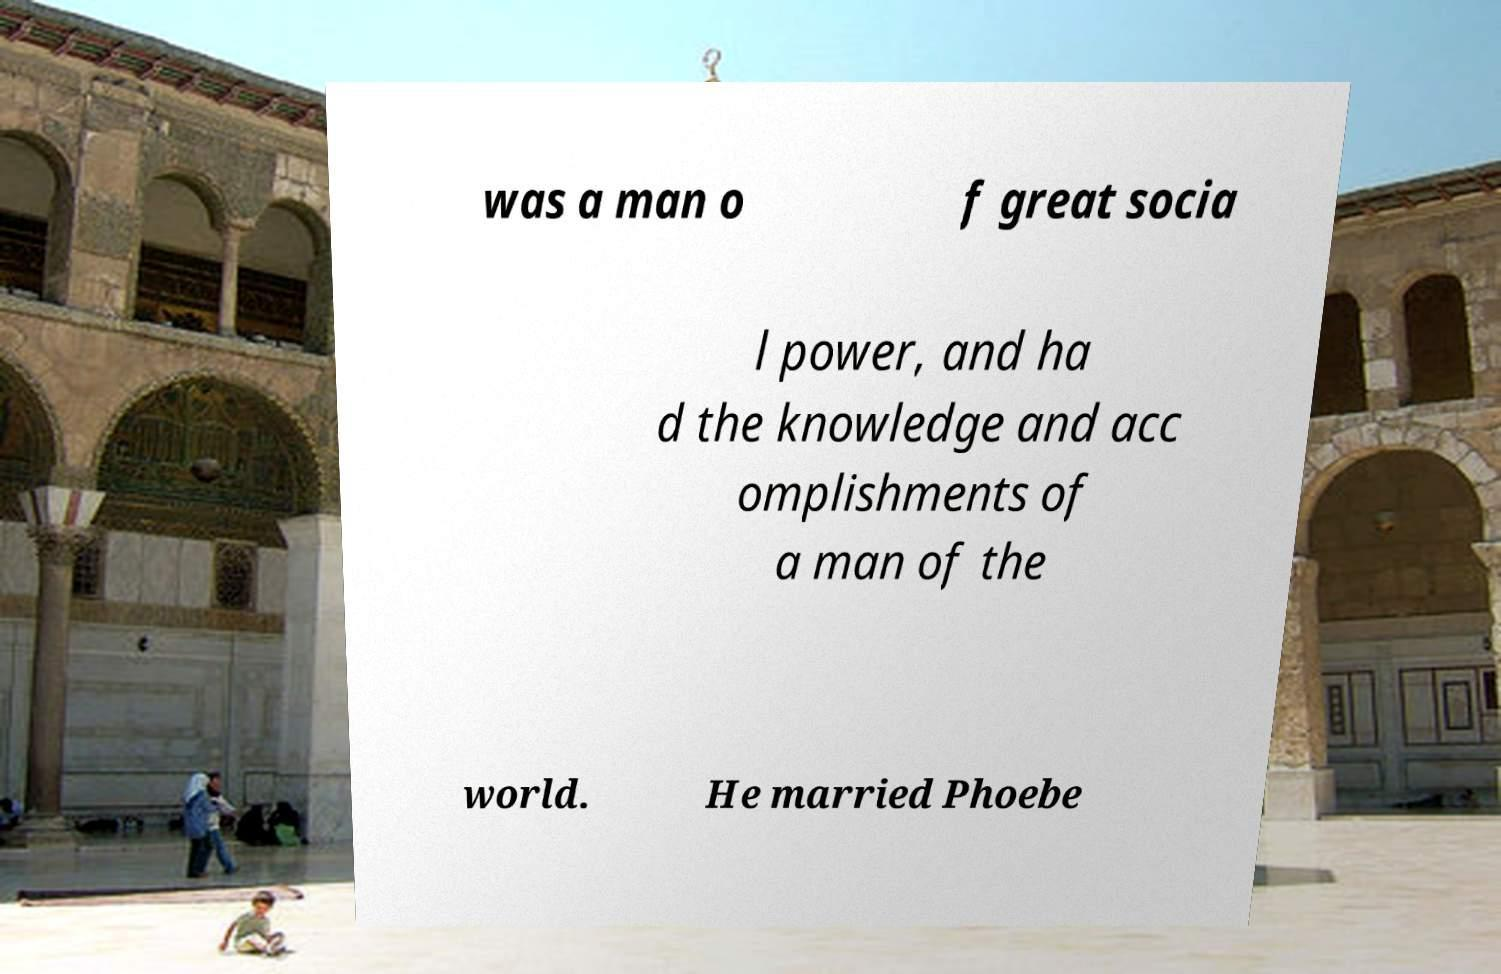There's text embedded in this image that I need extracted. Can you transcribe it verbatim? was a man o f great socia l power, and ha d the knowledge and acc omplishments of a man of the world. He married Phoebe 